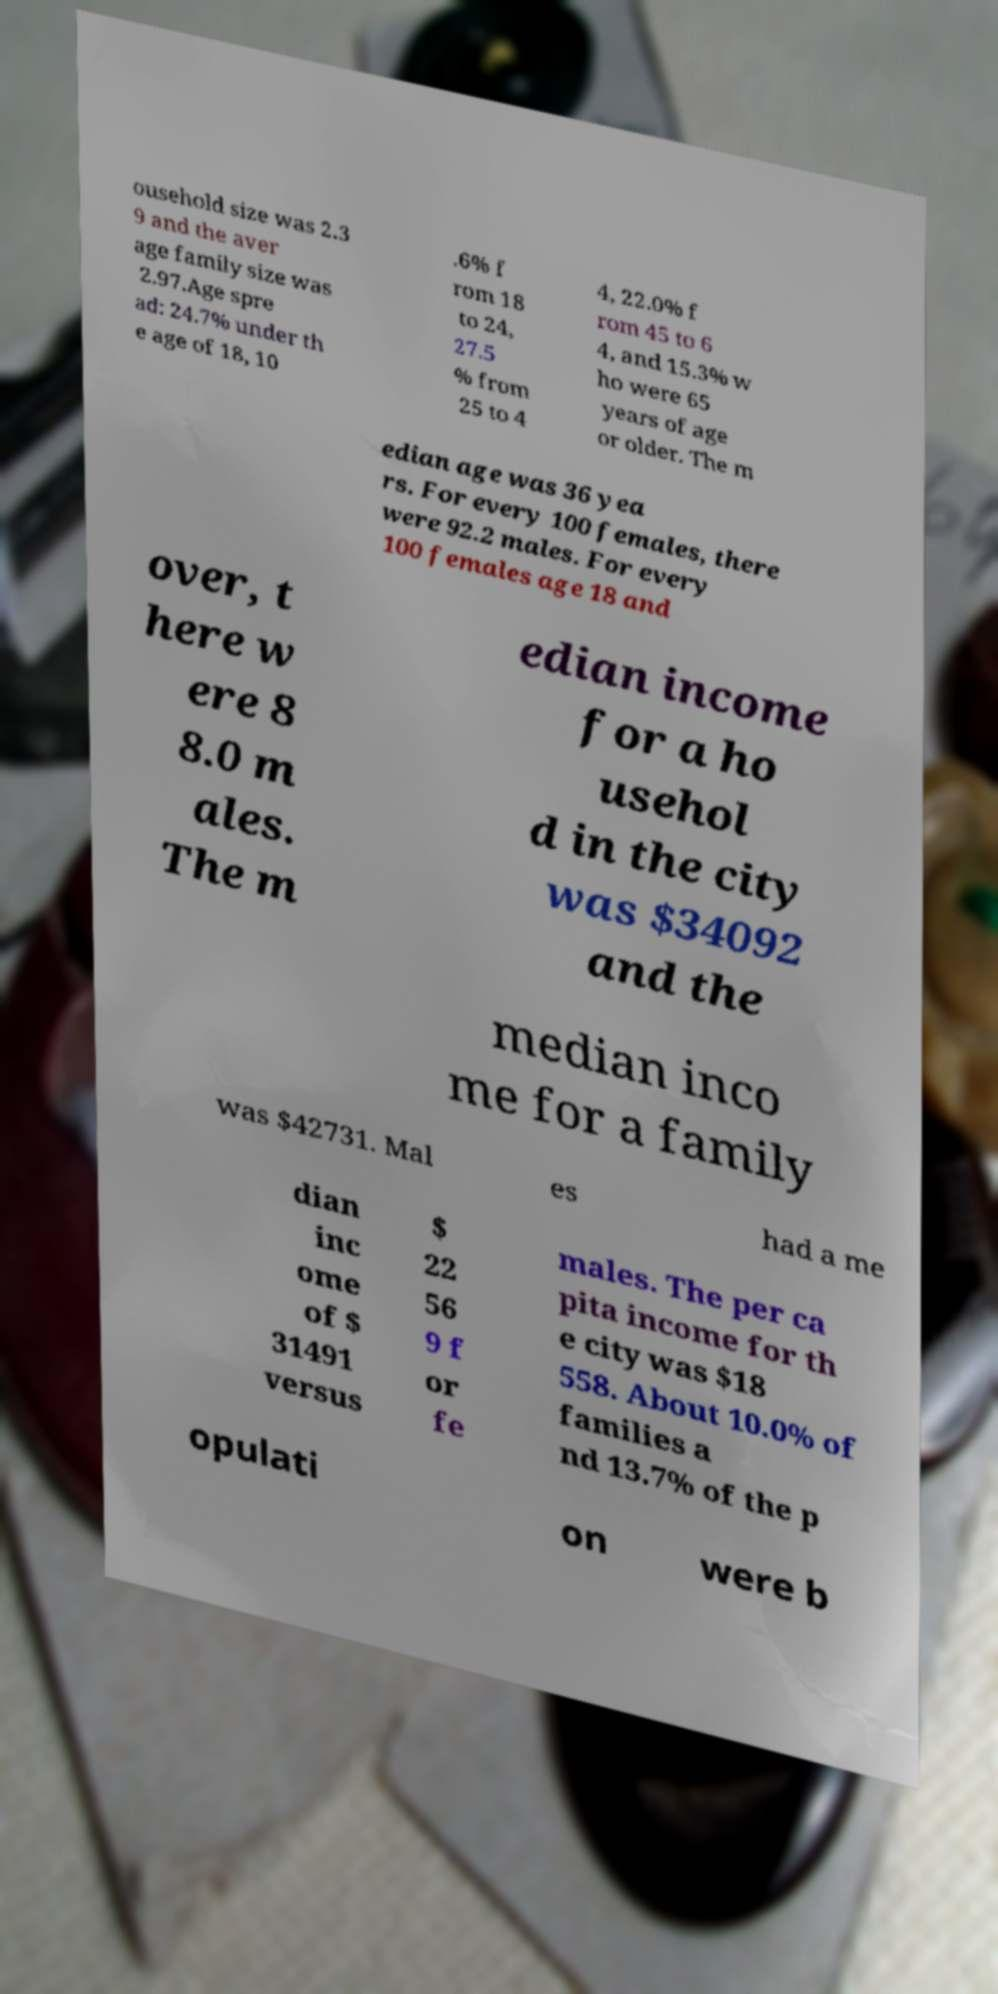For documentation purposes, I need the text within this image transcribed. Could you provide that? ousehold size was 2.3 9 and the aver age family size was 2.97.Age spre ad: 24.7% under th e age of 18, 10 .6% f rom 18 to 24, 27.5 % from 25 to 4 4, 22.0% f rom 45 to 6 4, and 15.3% w ho were 65 years of age or older. The m edian age was 36 yea rs. For every 100 females, there were 92.2 males. For every 100 females age 18 and over, t here w ere 8 8.0 m ales. The m edian income for a ho usehol d in the city was $34092 and the median inco me for a family was $42731. Mal es had a me dian inc ome of $ 31491 versus $ 22 56 9 f or fe males. The per ca pita income for th e city was $18 558. About 10.0% of families a nd 13.7% of the p opulati on were b 